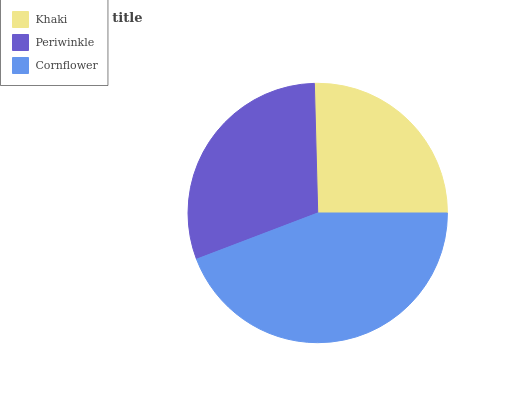Is Khaki the minimum?
Answer yes or no. Yes. Is Cornflower the maximum?
Answer yes or no. Yes. Is Periwinkle the minimum?
Answer yes or no. No. Is Periwinkle the maximum?
Answer yes or no. No. Is Periwinkle greater than Khaki?
Answer yes or no. Yes. Is Khaki less than Periwinkle?
Answer yes or no. Yes. Is Khaki greater than Periwinkle?
Answer yes or no. No. Is Periwinkle less than Khaki?
Answer yes or no. No. Is Periwinkle the high median?
Answer yes or no. Yes. Is Periwinkle the low median?
Answer yes or no. Yes. Is Khaki the high median?
Answer yes or no. No. Is Khaki the low median?
Answer yes or no. No. 